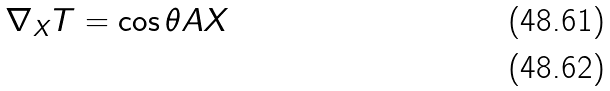<formula> <loc_0><loc_0><loc_500><loc_500>\nabla _ { X } T = \cos \theta A X \\</formula> 